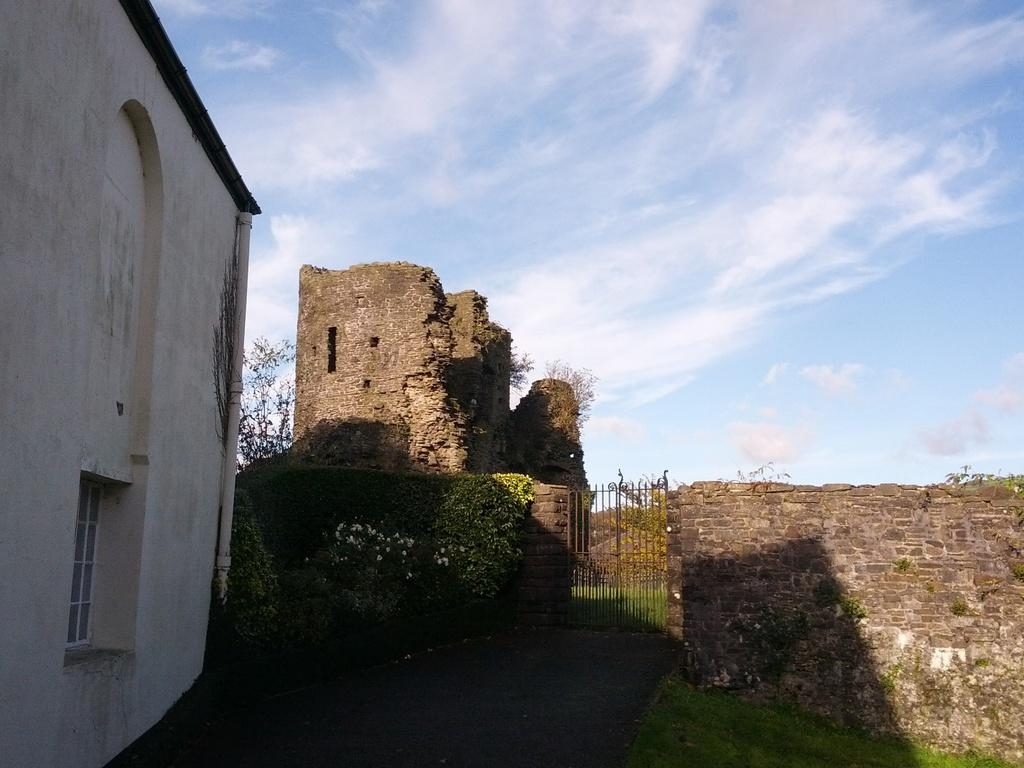What type of structures can be seen in the image? There are buildings in the image. What type of vegetation is present in the image? Creeper plants and trees are visible in the image. What objects are used for cooking in the image? Grills are visible in the image. What is visible in the background of the image? The sky is visible in the background of the image. What can be seen in the sky in the image? Clouds are present in the sky. Can you tell me how many spies are hiding behind the trees in the image? There is no indication of spies or any hidden individuals in the image; it features buildings, creeper plants, trees, grills, and a sky with clouds. What type of coach can be seen driving through the image? There is no coach or vehicle present in the image. 